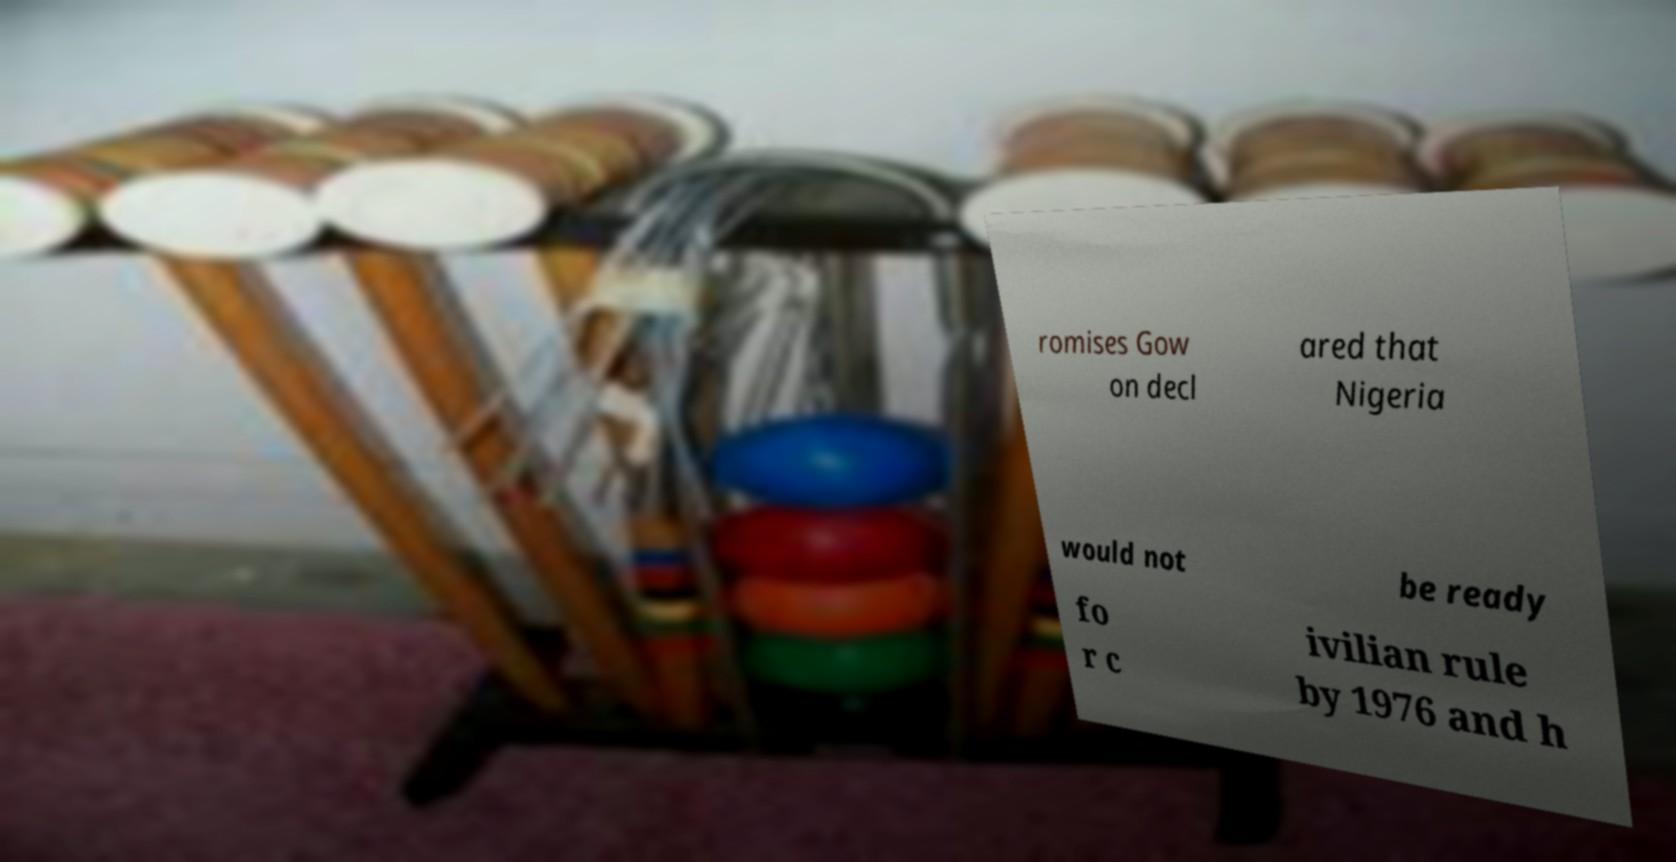For documentation purposes, I need the text within this image transcribed. Could you provide that? romises Gow on decl ared that Nigeria would not be ready fo r c ivilian rule by 1976 and h 